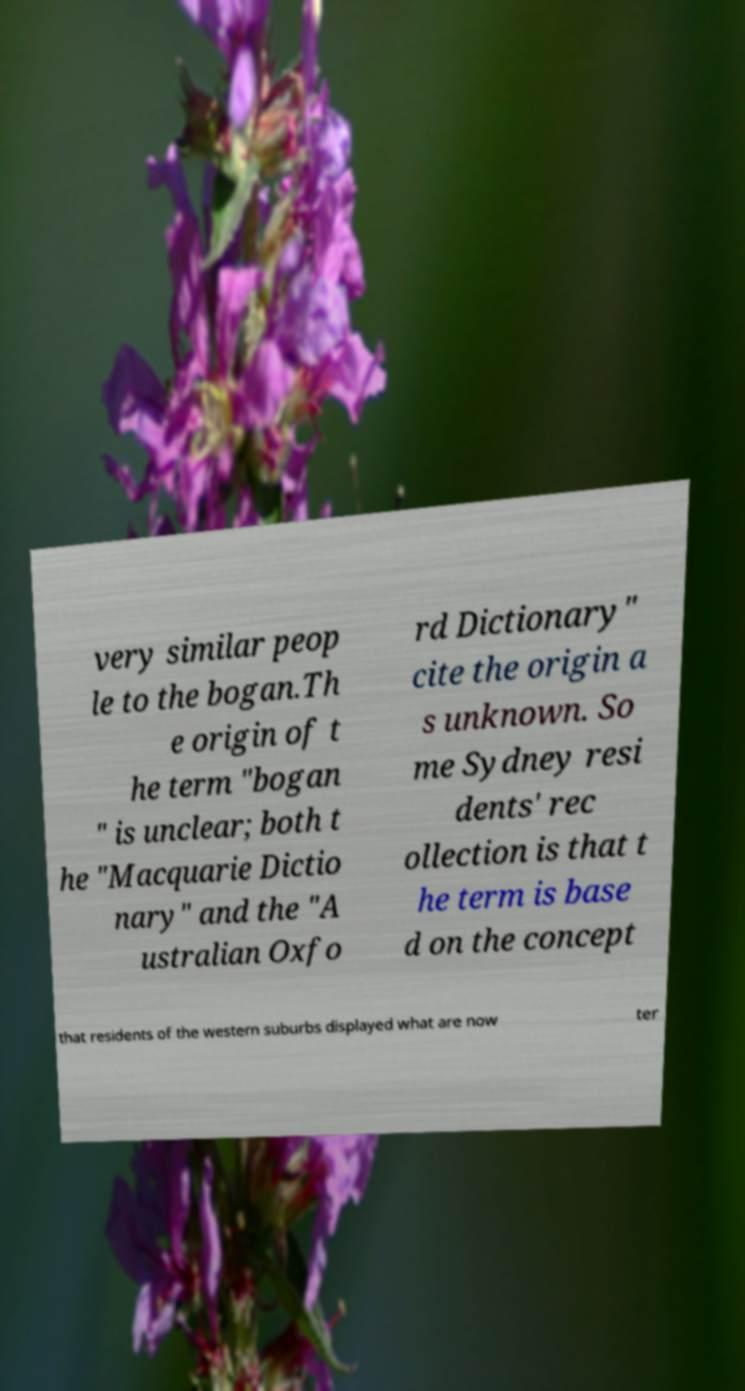Please identify and transcribe the text found in this image. very similar peop le to the bogan.Th e origin of t he term "bogan " is unclear; both t he "Macquarie Dictio nary" and the "A ustralian Oxfo rd Dictionary" cite the origin a s unknown. So me Sydney resi dents' rec ollection is that t he term is base d on the concept that residents of the western suburbs displayed what are now ter 